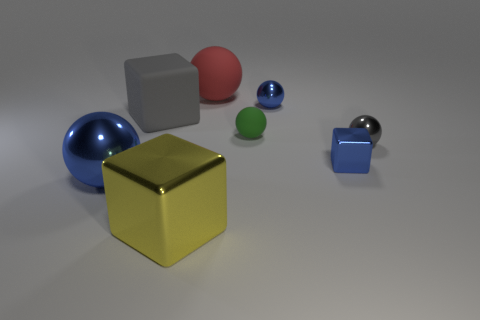What is the size of the ball that is the same color as the matte cube?
Keep it short and to the point. Small. The matte thing that is the same size as the red matte sphere is what color?
Ensure brevity in your answer.  Gray. There is a object in front of the shiny sphere that is left of the blue sphere that is behind the big gray object; what is it made of?
Ensure brevity in your answer.  Metal. Is the color of the tiny shiny block the same as the tiny metal sphere that is in front of the large gray rubber block?
Keep it short and to the point. No. What number of objects are blue metallic balls that are in front of the small blue block or blue balls behind the small gray shiny object?
Provide a short and direct response. 2. There is a matte thing that is behind the blue sphere that is to the right of the yellow metallic object; what is its shape?
Offer a very short reply. Sphere. Are there any big green cylinders that have the same material as the large red thing?
Your answer should be very brief. No. There is another large shiny thing that is the same shape as the gray metallic object; what is its color?
Provide a succinct answer. Blue. Are there fewer small blue balls on the right side of the blue cube than tiny rubber balls in front of the gray ball?
Keep it short and to the point. No. What number of other things are there of the same shape as the gray matte thing?
Your answer should be compact. 2. 